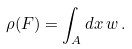<formula> <loc_0><loc_0><loc_500><loc_500>\rho ( F ) = \int _ { A } d x \, w \, .</formula> 